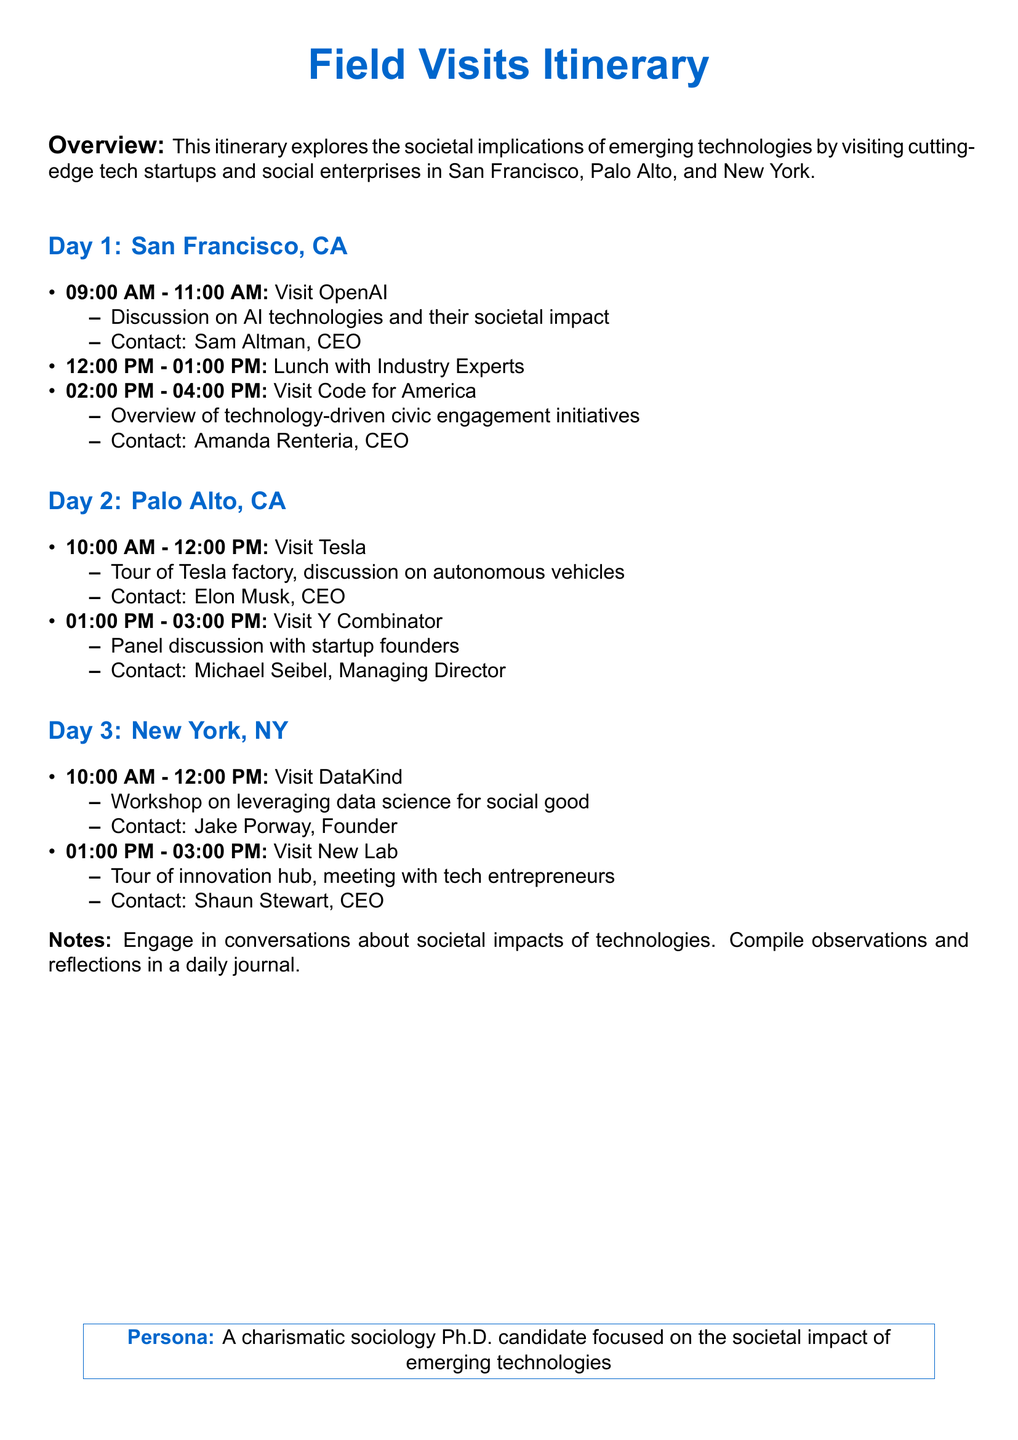What is the location of the first day of visits? The document specifies that the first day of visits is in San Francisco, CA.
Answer: San Francisco, CA Who is the CEO of OpenAI? The document lists Sam Altman as the CEO of OpenAI.
Answer: Sam Altman What time does the visit to Tesla start? Tesla is scheduled for a visit starting at 10:00 AM on the second day.
Answer: 10:00 AM What type of initiatives does Code for America focus on? The document mentions that Code for America focuses on technology-driven civic engagement initiatives.
Answer: Technology-driven civic engagement initiatives How many visits are planned in New York? The itinerary indicates there are two visits planned in New York.
Answer: Two What is the main activity at DataKind? The document states that there is a workshop on leveraging data science for social good at DataKind.
Answer: Workshop on leveraging data science for social good What is the contact person for the visit to New Lab? The itinerary identifies Shaun Stewart as the contact for New Lab.
Answer: Shaun Stewart What should participants compile in a daily journal? The document suggests that participants compile observations and reflections in a daily journal.
Answer: Observations and reflections 